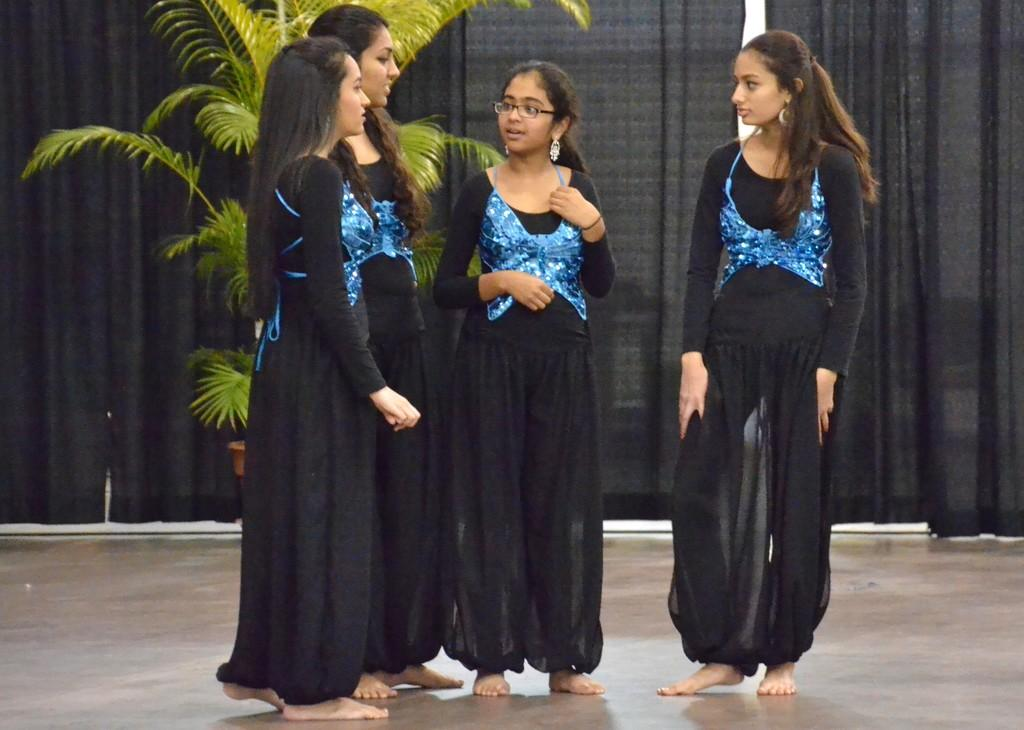Who is present in the foreground of the image? There are girls standing in the foreground of the image. What can be seen in the background of the image? There is a plant and black color curtains in the background of the image. What type of collar can be seen on the plant in the image? There is no collar present on the plant in the image, as plants do not wear collars. 